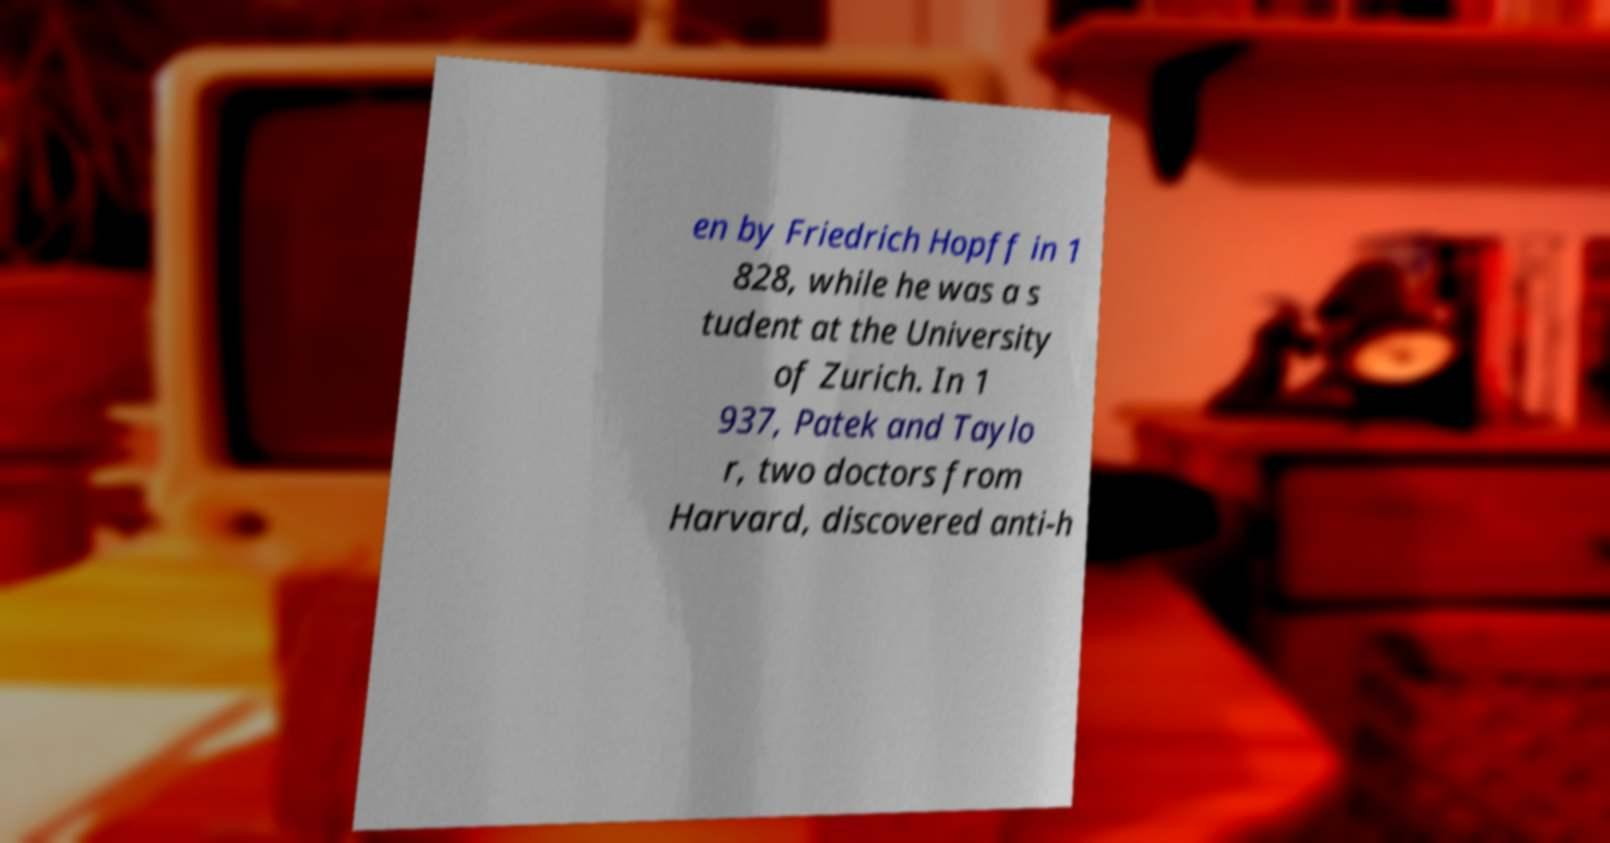For documentation purposes, I need the text within this image transcribed. Could you provide that? en by Friedrich Hopff in 1 828, while he was a s tudent at the University of Zurich. In 1 937, Patek and Taylo r, two doctors from Harvard, discovered anti-h 